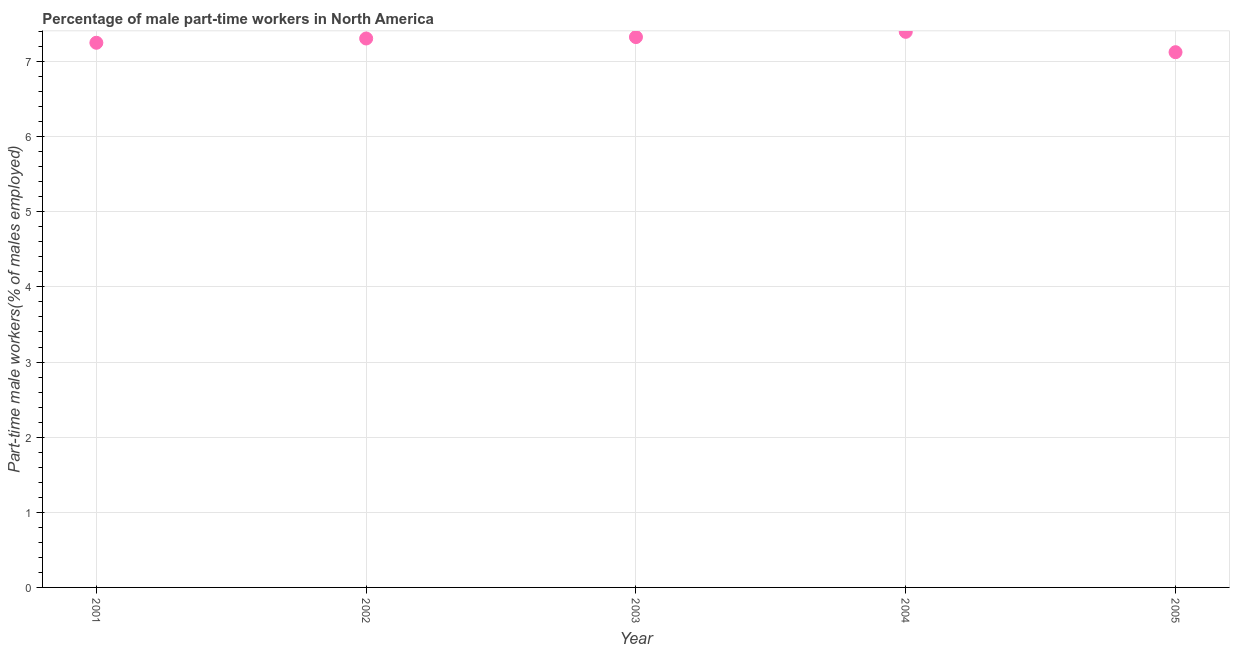What is the percentage of part-time male workers in 2005?
Provide a succinct answer. 7.12. Across all years, what is the maximum percentage of part-time male workers?
Keep it short and to the point. 7.39. Across all years, what is the minimum percentage of part-time male workers?
Keep it short and to the point. 7.12. In which year was the percentage of part-time male workers maximum?
Provide a short and direct response. 2004. What is the sum of the percentage of part-time male workers?
Your response must be concise. 36.4. What is the difference between the percentage of part-time male workers in 2003 and 2005?
Provide a succinct answer. 0.2. What is the average percentage of part-time male workers per year?
Your answer should be very brief. 7.28. What is the median percentage of part-time male workers?
Your answer should be very brief. 7.31. In how many years, is the percentage of part-time male workers greater than 2.8 %?
Your response must be concise. 5. Do a majority of the years between 2001 and 2005 (inclusive) have percentage of part-time male workers greater than 3.4 %?
Provide a short and direct response. Yes. What is the ratio of the percentage of part-time male workers in 2003 to that in 2005?
Your answer should be compact. 1.03. Is the difference between the percentage of part-time male workers in 2001 and 2002 greater than the difference between any two years?
Your answer should be very brief. No. What is the difference between the highest and the second highest percentage of part-time male workers?
Make the answer very short. 0.07. What is the difference between the highest and the lowest percentage of part-time male workers?
Make the answer very short. 0.27. In how many years, is the percentage of part-time male workers greater than the average percentage of part-time male workers taken over all years?
Keep it short and to the point. 3. Does the percentage of part-time male workers monotonically increase over the years?
Your answer should be very brief. No. How many dotlines are there?
Make the answer very short. 1. What is the difference between two consecutive major ticks on the Y-axis?
Provide a succinct answer. 1. Are the values on the major ticks of Y-axis written in scientific E-notation?
Give a very brief answer. No. Does the graph contain grids?
Keep it short and to the point. Yes. What is the title of the graph?
Provide a short and direct response. Percentage of male part-time workers in North America. What is the label or title of the Y-axis?
Keep it short and to the point. Part-time male workers(% of males employed). What is the Part-time male workers(% of males employed) in 2001?
Ensure brevity in your answer.  7.25. What is the Part-time male workers(% of males employed) in 2002?
Your answer should be compact. 7.31. What is the Part-time male workers(% of males employed) in 2003?
Your answer should be very brief. 7.33. What is the Part-time male workers(% of males employed) in 2004?
Offer a very short reply. 7.39. What is the Part-time male workers(% of males employed) in 2005?
Give a very brief answer. 7.12. What is the difference between the Part-time male workers(% of males employed) in 2001 and 2002?
Provide a succinct answer. -0.06. What is the difference between the Part-time male workers(% of males employed) in 2001 and 2003?
Give a very brief answer. -0.08. What is the difference between the Part-time male workers(% of males employed) in 2001 and 2004?
Provide a short and direct response. -0.15. What is the difference between the Part-time male workers(% of males employed) in 2001 and 2005?
Offer a terse response. 0.13. What is the difference between the Part-time male workers(% of males employed) in 2002 and 2003?
Your response must be concise. -0.02. What is the difference between the Part-time male workers(% of males employed) in 2002 and 2004?
Provide a short and direct response. -0.09. What is the difference between the Part-time male workers(% of males employed) in 2002 and 2005?
Ensure brevity in your answer.  0.18. What is the difference between the Part-time male workers(% of males employed) in 2003 and 2004?
Keep it short and to the point. -0.07. What is the difference between the Part-time male workers(% of males employed) in 2003 and 2005?
Give a very brief answer. 0.2. What is the difference between the Part-time male workers(% of males employed) in 2004 and 2005?
Your answer should be very brief. 0.27. What is the ratio of the Part-time male workers(% of males employed) in 2001 to that in 2003?
Offer a very short reply. 0.99. What is the ratio of the Part-time male workers(% of males employed) in 2001 to that in 2004?
Keep it short and to the point. 0.98. What is the ratio of the Part-time male workers(% of males employed) in 2001 to that in 2005?
Give a very brief answer. 1.02. What is the ratio of the Part-time male workers(% of males employed) in 2002 to that in 2003?
Offer a terse response. 1. What is the ratio of the Part-time male workers(% of males employed) in 2002 to that in 2004?
Make the answer very short. 0.99. What is the ratio of the Part-time male workers(% of males employed) in 2002 to that in 2005?
Provide a succinct answer. 1.03. What is the ratio of the Part-time male workers(% of males employed) in 2003 to that in 2004?
Keep it short and to the point. 0.99. What is the ratio of the Part-time male workers(% of males employed) in 2003 to that in 2005?
Your response must be concise. 1.03. What is the ratio of the Part-time male workers(% of males employed) in 2004 to that in 2005?
Keep it short and to the point. 1.04. 